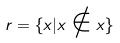Convert formula to latex. <formula><loc_0><loc_0><loc_500><loc_500>r = \{ x | x \notin x \}</formula> 